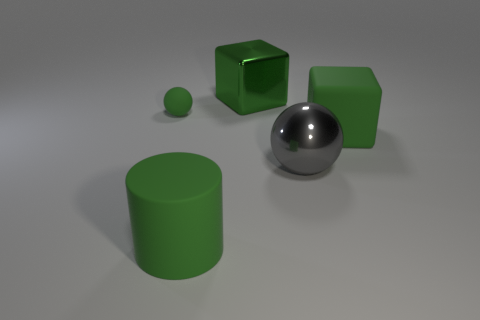There is a cylinder that is the same color as the tiny sphere; what material is it?
Ensure brevity in your answer.  Rubber. Is the material of the ball that is on the left side of the big gray ball the same as the big block that is to the left of the big gray ball?
Make the answer very short. No. What size is the block that is on the left side of the big green object that is to the right of the ball right of the small matte ball?
Provide a succinct answer. Large. There is a green cylinder that is the same size as the metal ball; what is it made of?
Your answer should be very brief. Rubber. Is there a purple shiny thing that has the same size as the gray ball?
Ensure brevity in your answer.  No. Does the gray metal object have the same shape as the tiny green rubber object?
Your response must be concise. Yes. Are there any objects in front of the large green thing that is to the right of the cube that is on the left side of the large matte cube?
Your answer should be very brief. Yes. What number of other things are there of the same color as the metallic block?
Provide a succinct answer. 3. Is the size of the rubber sphere that is on the left side of the cylinder the same as the green rubber thing that is to the right of the green matte cylinder?
Give a very brief answer. No. Are there the same number of tiny things behind the green shiny object and big rubber cubes that are behind the green rubber cube?
Ensure brevity in your answer.  Yes. 